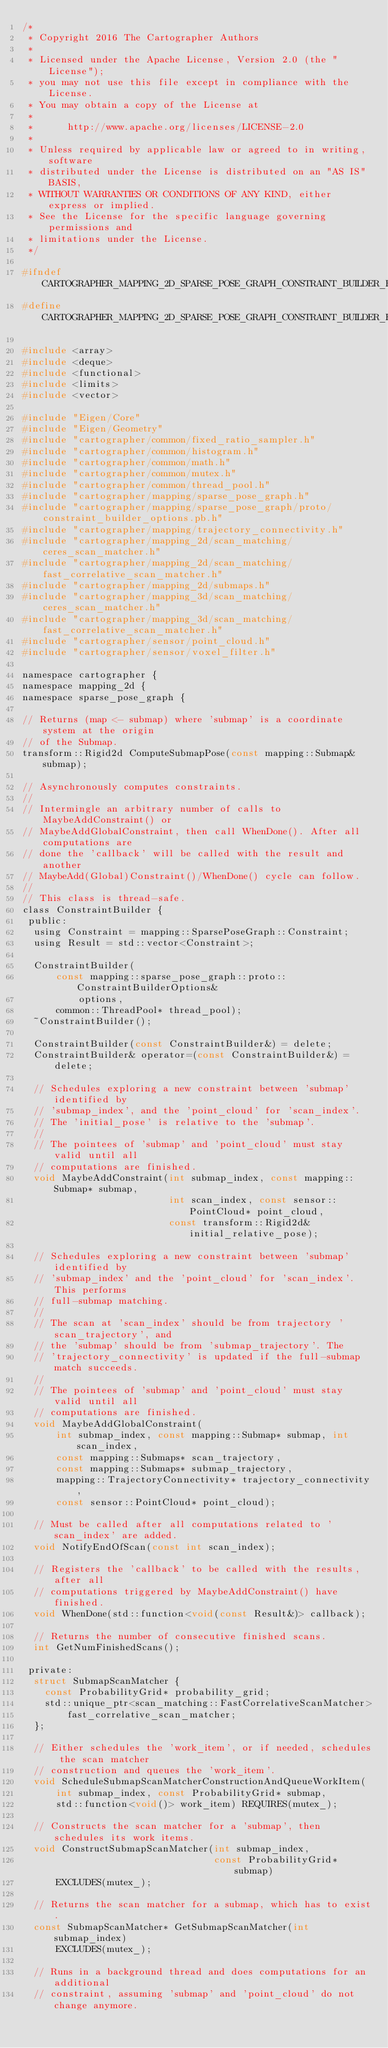<code> <loc_0><loc_0><loc_500><loc_500><_C_>/*
 * Copyright 2016 The Cartographer Authors
 *
 * Licensed under the Apache License, Version 2.0 (the "License");
 * you may not use this file except in compliance with the License.
 * You may obtain a copy of the License at
 *
 *      http://www.apache.org/licenses/LICENSE-2.0
 *
 * Unless required by applicable law or agreed to in writing, software
 * distributed under the License is distributed on an "AS IS" BASIS,
 * WITHOUT WARRANTIES OR CONDITIONS OF ANY KIND, either express or implied.
 * See the License for the specific language governing permissions and
 * limitations under the License.
 */

#ifndef CARTOGRAPHER_MAPPING_2D_SPARSE_POSE_GRAPH_CONSTRAINT_BUILDER_H_
#define CARTOGRAPHER_MAPPING_2D_SPARSE_POSE_GRAPH_CONSTRAINT_BUILDER_H_

#include <array>
#include <deque>
#include <functional>
#include <limits>
#include <vector>

#include "Eigen/Core"
#include "Eigen/Geometry"
#include "cartographer/common/fixed_ratio_sampler.h"
#include "cartographer/common/histogram.h"
#include "cartographer/common/math.h"
#include "cartographer/common/mutex.h"
#include "cartographer/common/thread_pool.h"
#include "cartographer/mapping/sparse_pose_graph.h"
#include "cartographer/mapping/sparse_pose_graph/proto/constraint_builder_options.pb.h"
#include "cartographer/mapping/trajectory_connectivity.h"
#include "cartographer/mapping_2d/scan_matching/ceres_scan_matcher.h"
#include "cartographer/mapping_2d/scan_matching/fast_correlative_scan_matcher.h"
#include "cartographer/mapping_2d/submaps.h"
#include "cartographer/mapping_3d/scan_matching/ceres_scan_matcher.h"
#include "cartographer/mapping_3d/scan_matching/fast_correlative_scan_matcher.h"
#include "cartographer/sensor/point_cloud.h"
#include "cartographer/sensor/voxel_filter.h"

namespace cartographer {
namespace mapping_2d {
namespace sparse_pose_graph {

// Returns (map <- submap) where 'submap' is a coordinate system at the origin
// of the Submap.
transform::Rigid2d ComputeSubmapPose(const mapping::Submap& submap);

// Asynchronously computes constraints.
//
// Intermingle an arbitrary number of calls to MaybeAddConstraint() or
// MaybeAddGlobalConstraint, then call WhenDone(). After all computations are
// done the 'callback' will be called with the result and another
// MaybeAdd(Global)Constraint()/WhenDone() cycle can follow.
//
// This class is thread-safe.
class ConstraintBuilder {
 public:
  using Constraint = mapping::SparsePoseGraph::Constraint;
  using Result = std::vector<Constraint>;

  ConstraintBuilder(
      const mapping::sparse_pose_graph::proto::ConstraintBuilderOptions&
          options,
      common::ThreadPool* thread_pool);
  ~ConstraintBuilder();

  ConstraintBuilder(const ConstraintBuilder&) = delete;
  ConstraintBuilder& operator=(const ConstraintBuilder&) = delete;

  // Schedules exploring a new constraint between 'submap' identified by
  // 'submap_index', and the 'point_cloud' for 'scan_index'.
  // The 'initial_pose' is relative to the 'submap'.
  //
  // The pointees of 'submap' and 'point_cloud' must stay valid until all
  // computations are finished.
  void MaybeAddConstraint(int submap_index, const mapping::Submap* submap,
                          int scan_index, const sensor::PointCloud* point_cloud,
                          const transform::Rigid2d& initial_relative_pose);

  // Schedules exploring a new constraint between 'submap' identified by
  // 'submap_index' and the 'point_cloud' for 'scan_index'. This performs
  // full-submap matching.
  //
  // The scan at 'scan_index' should be from trajectory 'scan_trajectory', and
  // the 'submap' should be from 'submap_trajectory'. The
  // 'trajectory_connectivity' is updated if the full-submap match succeeds.
  //
  // The pointees of 'submap' and 'point_cloud' must stay valid until all
  // computations are finished.
  void MaybeAddGlobalConstraint(
      int submap_index, const mapping::Submap* submap, int scan_index,
      const mapping::Submaps* scan_trajectory,
      const mapping::Submaps* submap_trajectory,
      mapping::TrajectoryConnectivity* trajectory_connectivity,
      const sensor::PointCloud* point_cloud);

  // Must be called after all computations related to 'scan_index' are added.
  void NotifyEndOfScan(const int scan_index);

  // Registers the 'callback' to be called with the results, after all
  // computations triggered by MaybeAddConstraint() have finished.
  void WhenDone(std::function<void(const Result&)> callback);

  // Returns the number of consecutive finished scans.
  int GetNumFinishedScans();

 private:
  struct SubmapScanMatcher {
    const ProbabilityGrid* probability_grid;
    std::unique_ptr<scan_matching::FastCorrelativeScanMatcher>
        fast_correlative_scan_matcher;
  };

  // Either schedules the 'work_item', or if needed, schedules the scan matcher
  // construction and queues the 'work_item'.
  void ScheduleSubmapScanMatcherConstructionAndQueueWorkItem(
      int submap_index, const ProbabilityGrid* submap,
      std::function<void()> work_item) REQUIRES(mutex_);

  // Constructs the scan matcher for a 'submap', then schedules its work items.
  void ConstructSubmapScanMatcher(int submap_index,
                                  const ProbabilityGrid* submap)
      EXCLUDES(mutex_);

  // Returns the scan matcher for a submap, which has to exist.
  const SubmapScanMatcher* GetSubmapScanMatcher(int submap_index)
      EXCLUDES(mutex_);

  // Runs in a background thread and does computations for an additional
  // constraint, assuming 'submap' and 'point_cloud' do not change anymore.</code> 